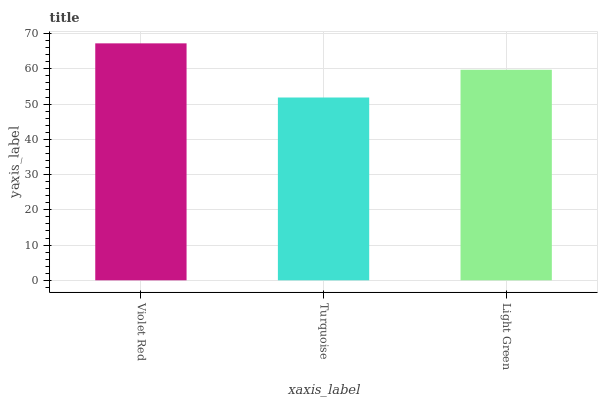Is Light Green the minimum?
Answer yes or no. No. Is Light Green the maximum?
Answer yes or no. No. Is Light Green greater than Turquoise?
Answer yes or no. Yes. Is Turquoise less than Light Green?
Answer yes or no. Yes. Is Turquoise greater than Light Green?
Answer yes or no. No. Is Light Green less than Turquoise?
Answer yes or no. No. Is Light Green the high median?
Answer yes or no. Yes. Is Light Green the low median?
Answer yes or no. Yes. Is Violet Red the high median?
Answer yes or no. No. Is Turquoise the low median?
Answer yes or no. No. 